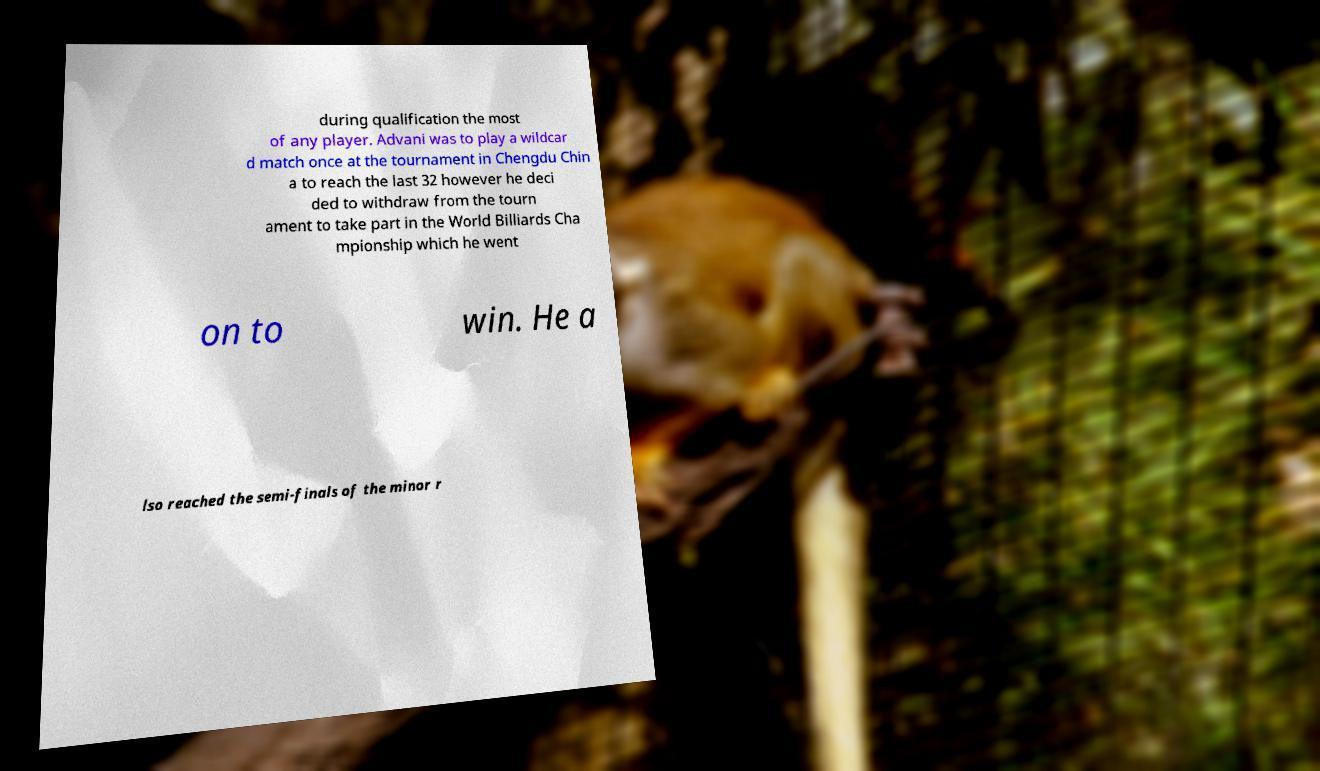Please read and relay the text visible in this image. What does it say? during qualification the most of any player. Advani was to play a wildcar d match once at the tournament in Chengdu Chin a to reach the last 32 however he deci ded to withdraw from the tourn ament to take part in the World Billiards Cha mpionship which he went on to win. He a lso reached the semi-finals of the minor r 